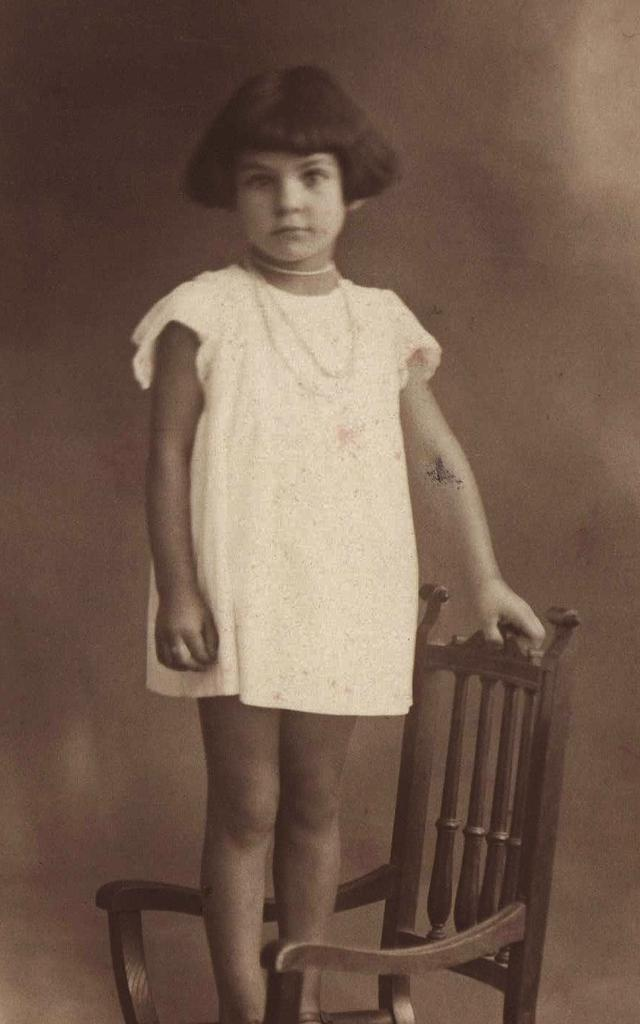What is the main subject of the image? The main subject of the image is a small girl. What is the girl doing in the image? The girl is standing on a chair and smiling. What is the girl wearing in the image? The girl is wearing a white frock. How is the girl holding the chair? The girl is holding the chair with her left hand. What can be seen in the background of the image? There is a wall in the background of the image. Who is the girl arguing with in the image? There is no argument or other person present in the image; the girl is simply standing on a chair and smiling. 